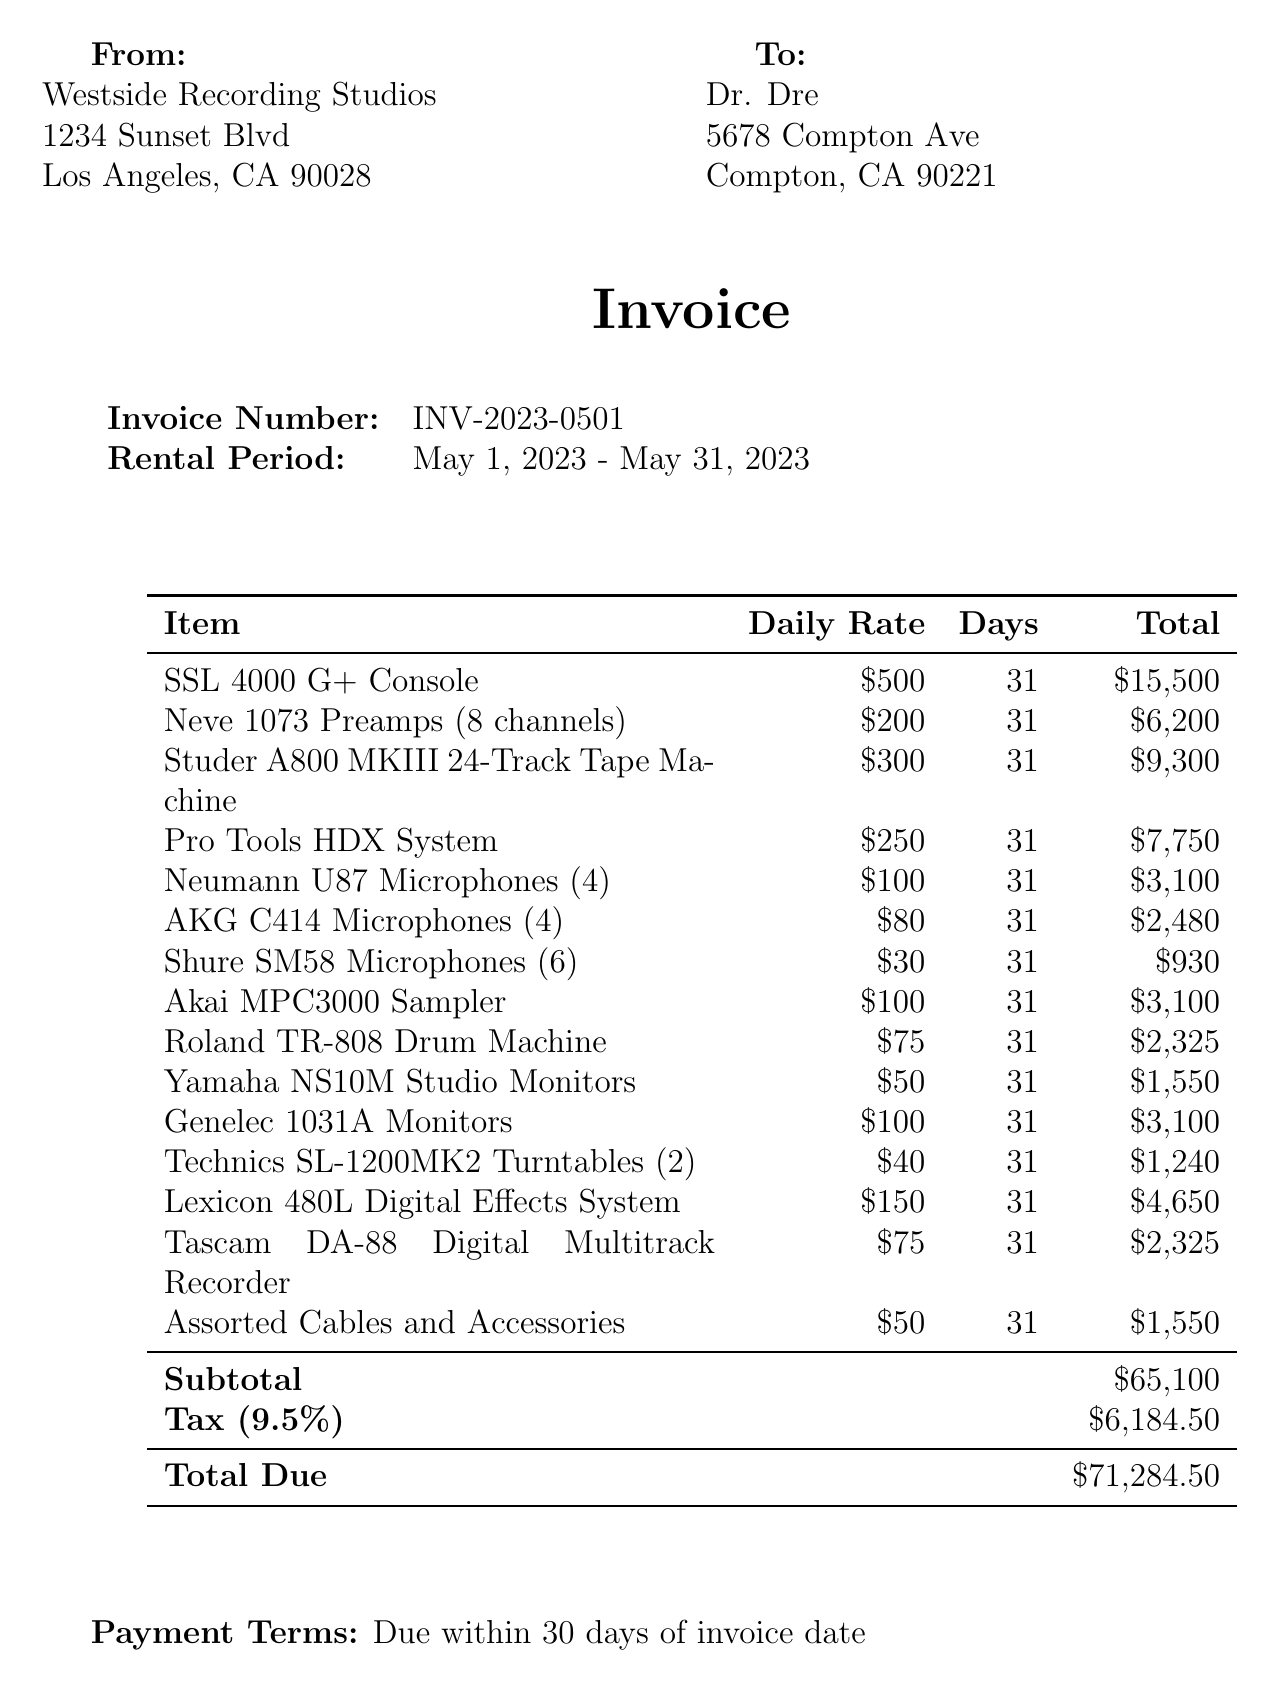what is the invoice number? The invoice number is clearly listed in the document for reference.
Answer: INV-2023-0501 what is the rental period? The rental period specifies the duration of the studio equipment rental.
Answer: May 1, 2023 - May 31, 2023 who is the client? The client's name is identified at the top of the invoice.
Answer: Dr. Dre what is the subtotal amount? The subtotal is the sum of all rental items before tax.
Answer: $65,100 what is the daily rate of the SSL 4000 G+ Console? The daily rate for this specific piece of equipment is provided in the itemized list.
Answer: $500 how many days was the equipment rented for? The number of days for which the equipment was rented is indicated in the invoice.
Answer: 31 what is the tax rate applied? The tax rate is stated in the invoice document.
Answer: 9.5% what is the total due? The total amount that needs to be paid, including tax, is specified at the bottom of the invoice.
Answer: $71,284.50 what is the address of Westside Recording Studios? The address for the studio is provided in the heading section of the invoice.
Answer: 1234 Sunset Blvd, Los Angeles, CA 90028 what are the payment terms? The payment terms detail when payment is expected to be made.
Answer: Due within 30 days of invoice date 